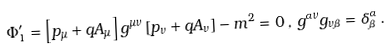Convert formula to latex. <formula><loc_0><loc_0><loc_500><loc_500>\Phi _ { 1 } ^ { \prime } = \left [ p _ { \mu } + q A _ { \mu } \right ] g ^ { \mu \nu } \left [ p _ { \nu } + q A _ { \nu } \right ] - m ^ { 2 } = 0 \, , \, g ^ { \alpha \nu } g _ { \nu \beta } = \delta _ { \beta } ^ { \alpha } \, .</formula> 